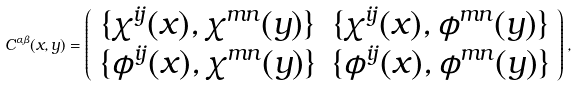<formula> <loc_0><loc_0><loc_500><loc_500>C ^ { \alpha \beta } ( x , y ) = \left ( \begin{array} { c c } \{ \chi ^ { i j } ( x ) , \chi ^ { m n } ( y ) \} & \{ \chi ^ { i j } ( x ) , \phi ^ { m n } ( y ) \} \\ \{ \phi ^ { i j } ( x ) , \chi ^ { m n } ( y ) \} & \{ \phi ^ { i j } ( x ) , \phi ^ { m n } ( y ) \} \end{array} \right ) ,</formula> 